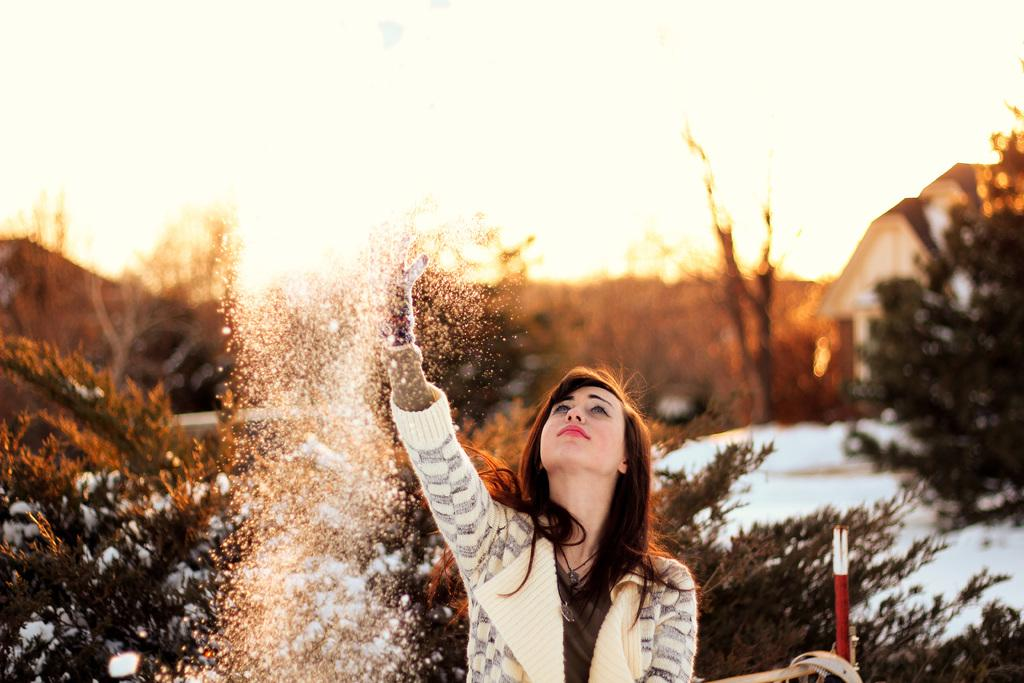Who is the main subject in the image? There is a woman in the center of the image. What is the weather like in the image? There is snow visible in the image, indicating a cold or wintery setting. What type of structure can be seen in the image? There is a house in the image. What type of vegetation is present in the image? There are trees in the image. What is visible in the background of the image? The sky is visible in the image. What object is located on the right side of the image? There is a rod on the right side of the image. What type of animal can be seen interacting with the woman in the image? There are no animals visible in the image. 